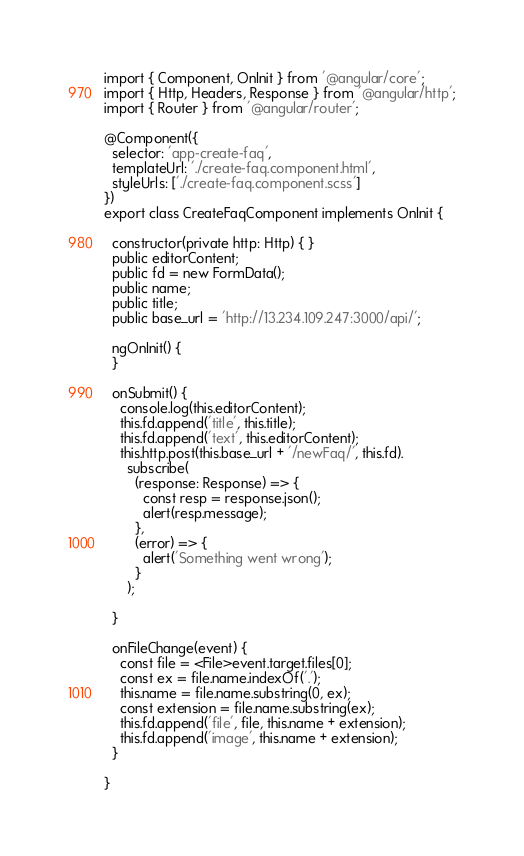<code> <loc_0><loc_0><loc_500><loc_500><_TypeScript_>import { Component, OnInit } from '@angular/core';
import { Http, Headers, Response } from '@angular/http';
import { Router } from '@angular/router';

@Component({
  selector: 'app-create-faq',
  templateUrl: './create-faq.component.html',
  styleUrls: ['./create-faq.component.scss']
})
export class CreateFaqComponent implements OnInit {

  constructor(private http: Http) { }
  public editorContent;
  public fd = new FormData();
  public name;
  public title;
  public base_url = 'http://13.234.109.247:3000/api/';

  ngOnInit() {
  }

  onSubmit() {
    console.log(this.editorContent);
    this.fd.append('title', this.title);
    this.fd.append('text', this.editorContent);
    this.http.post(this.base_url + '/newFaq/', this.fd).
      subscribe(
        (response: Response) => {
          const resp = response.json();
          alert(resp.message);
        },
        (error) => {
          alert('Something went wrong');
        }
      );

  }

  onFileChange(event) {
    const file = <File>event.target.files[0];
    const ex = file.name.indexOf('.');
    this.name = file.name.substring(0, ex);
    const extension = file.name.substring(ex);
    this.fd.append('file', file, this.name + extension);
    this.fd.append('image', this.name + extension);
  }

}
</code> 